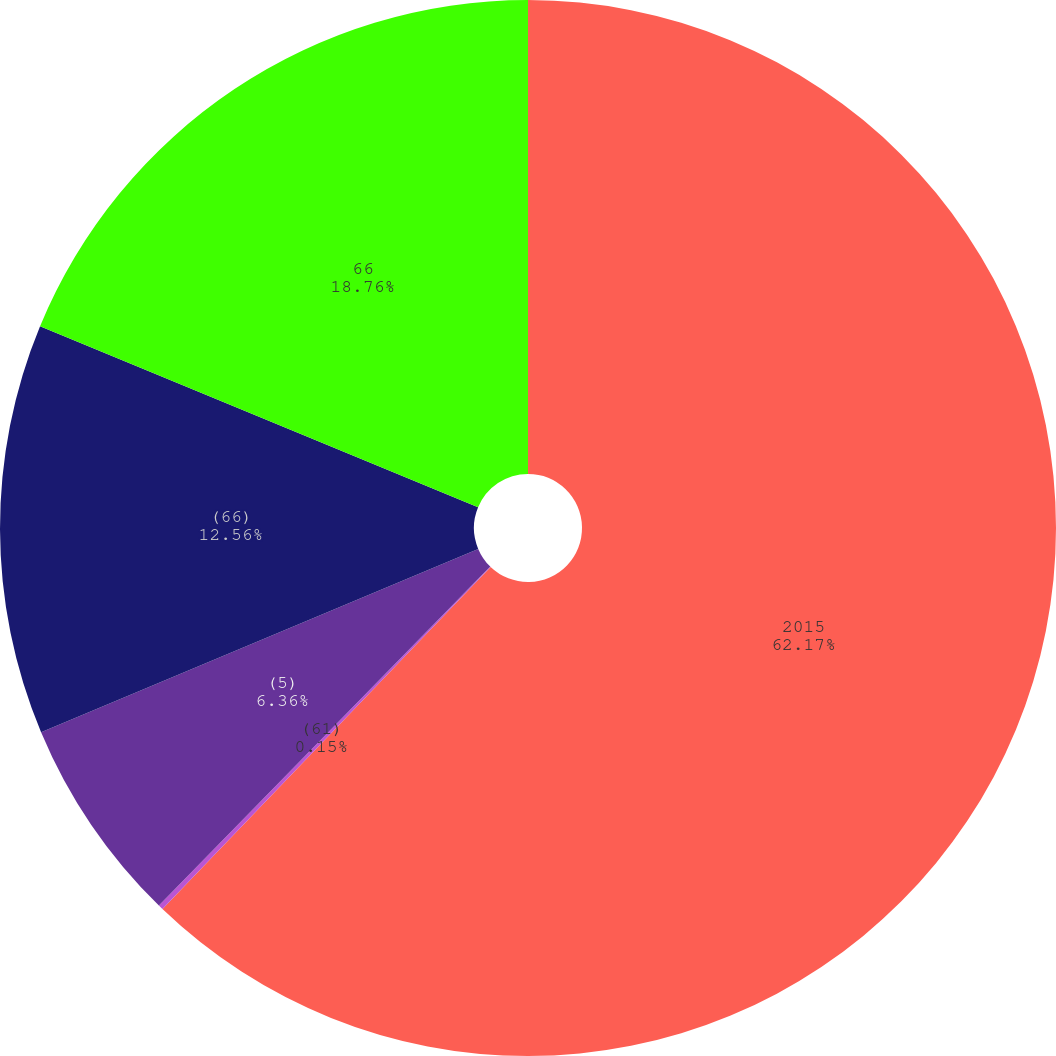Convert chart to OTSL. <chart><loc_0><loc_0><loc_500><loc_500><pie_chart><fcel>2015<fcel>(61)<fcel>(5)<fcel>(66)<fcel>66<nl><fcel>62.17%<fcel>0.15%<fcel>6.36%<fcel>12.56%<fcel>18.76%<nl></chart> 